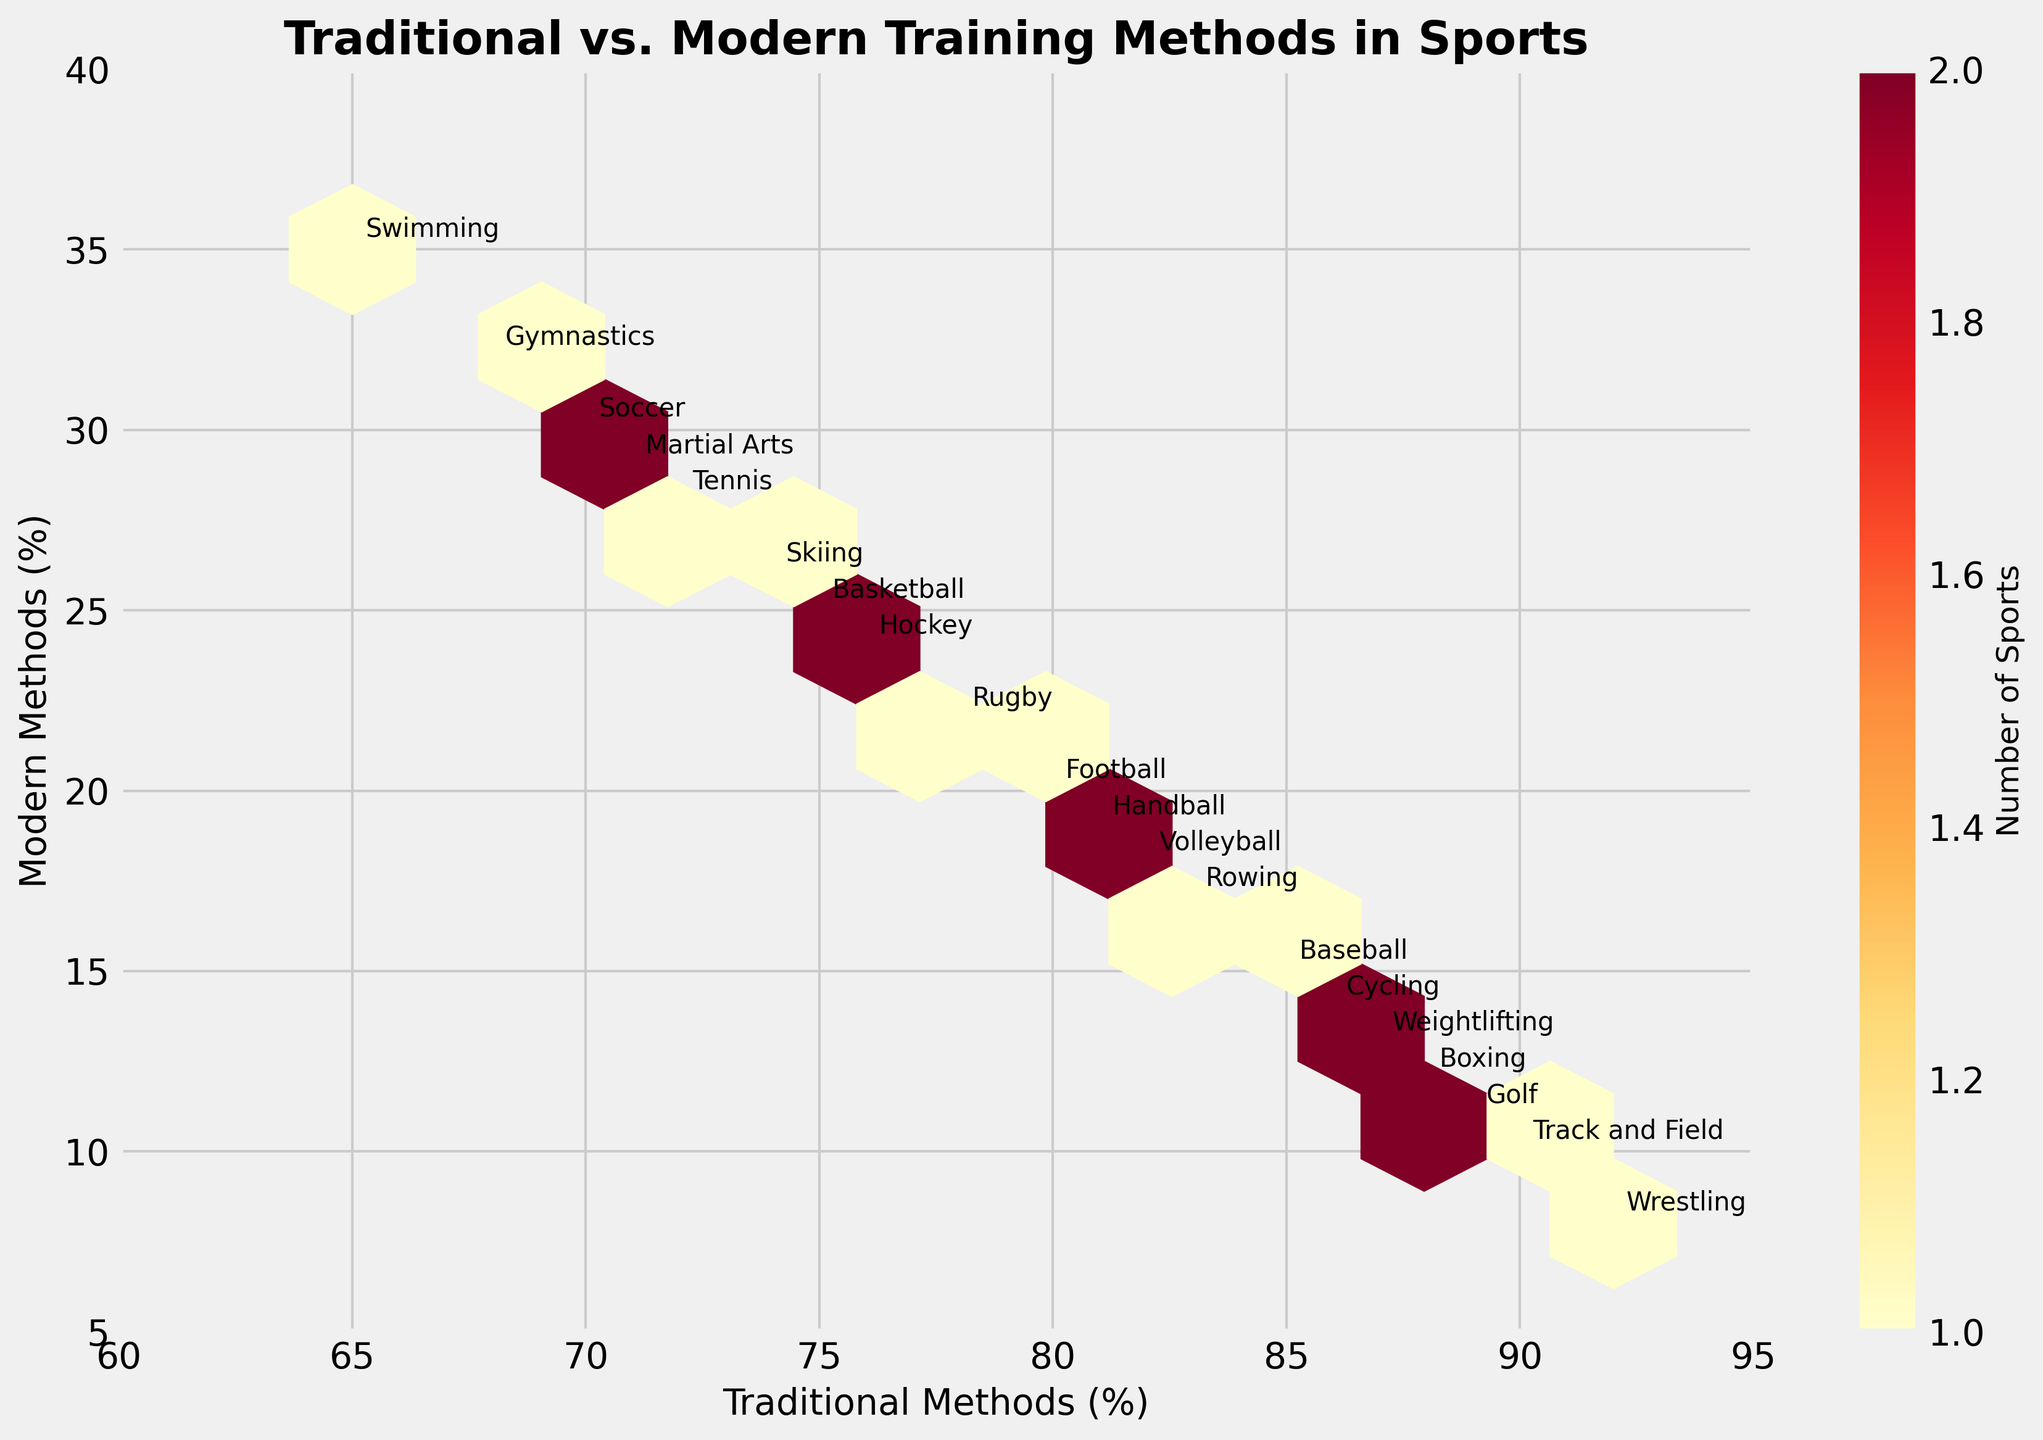what is the title of the figure? The title is displayed at the top of the figure, typically in larger, bold font to summarize the entire plot.
Answer: Traditional vs. Modern Training Methods in Sports What's the range of traditional methods percentage covered in the plot? On the x-axis of the plot, the range is marked, starting from the minimal value to the maximal value shown.
Answer: 60% to 95% How many sports utilize 70% to 80% traditional methods against 20% to 30% modern methods? Identify the hexagons within the specified ranges on both axes. Count the number of hexagons that fall into these intervals.
Answer: 4 Which sport utilizes the highest percentage of traditional methods? Locate the highest value on the x-axis, then find the corresponding sport labeled near this value.
Answer: Wrestling Which sport utilizes the lowest percentage of traditional methods? Locate the lowest value on the x-axis, then find the corresponding sport labeled near this value.
Answer: Swimming How many sports use more than 80% traditional methods? Identify and count the hexagons whose x-values (traditional methods) are greater than 80%.
Answer: 10 Which sport has the widest gap between traditional and modern methods? Calculate the difference between the traditional and modern methods for each sport, identify the one with the largest difference.
Answer: Wrestling (92% traditional, 8% modern = 84% gap) Which sport has the narrowest gap between traditional and modern methods? Calculate the difference between the traditional and modern methods for each sport, identify the one with the smallest difference.
Answer: Swimming (65% traditional, 35% modern = 30% gap) What is the color representing the highest number of sports within a single hexagon? Look at the color bar legend to determine which color represents the maximum value and find that color in the hexagons.
Answer: Darkest red Do more sports have traditional methods in the range of 75% to 85% or modern methods in the range of 10% to 20%? Count the hexagons that fall into each of these ranges, compare the counts.
Answer: Traditional methods (75%-85%) 